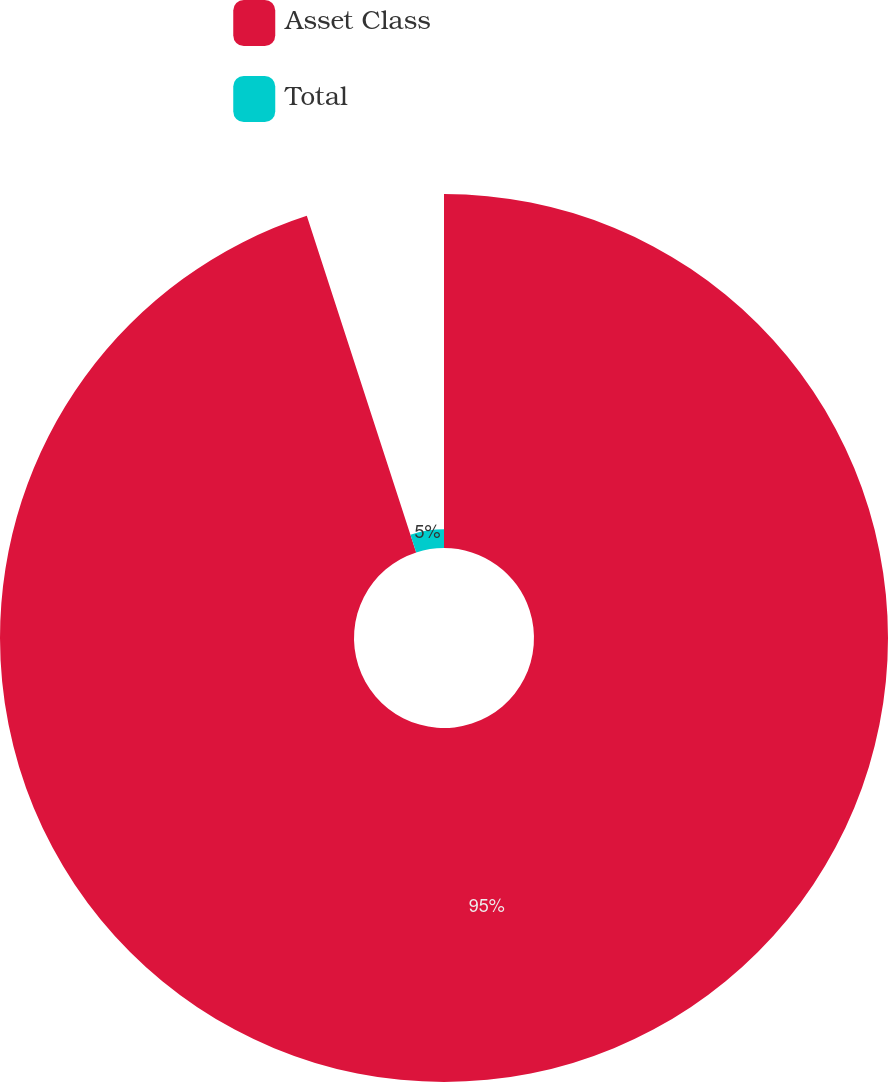<chart> <loc_0><loc_0><loc_500><loc_500><pie_chart><fcel>Asset Class<fcel>Total<nl><fcel>95.0%<fcel>5.0%<nl></chart> 